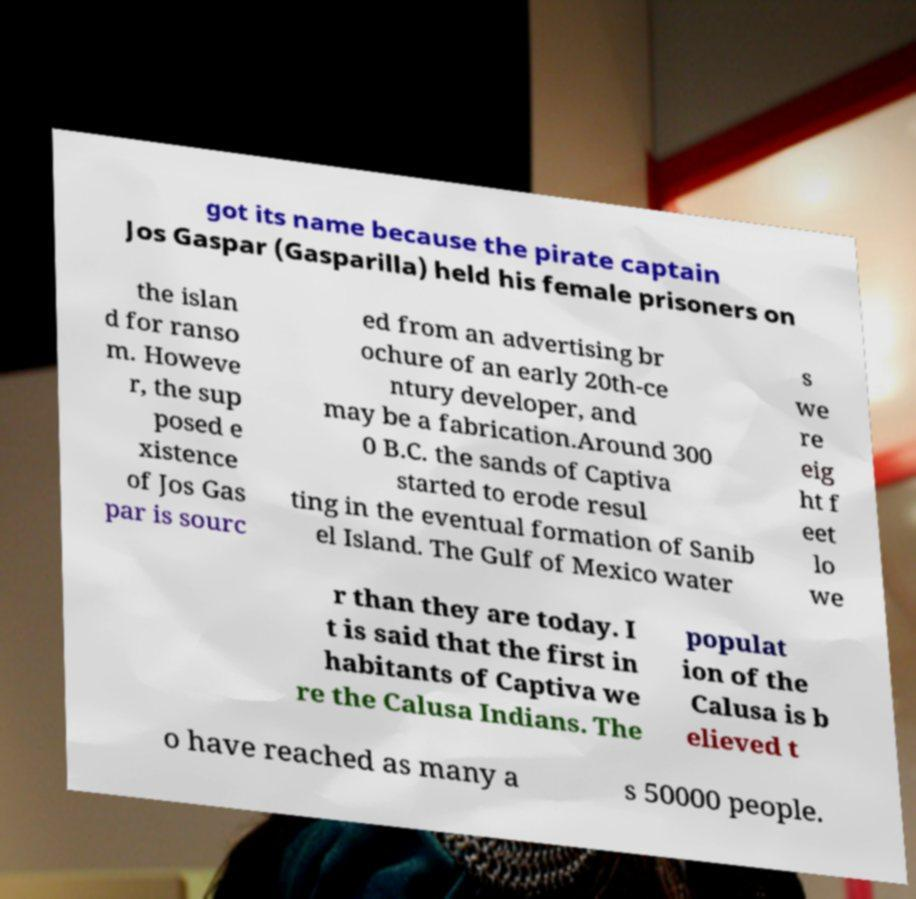Please read and relay the text visible in this image. What does it say? got its name because the pirate captain Jos Gaspar (Gasparilla) held his female prisoners on the islan d for ranso m. Howeve r, the sup posed e xistence of Jos Gas par is sourc ed from an advertising br ochure of an early 20th-ce ntury developer, and may be a fabrication.Around 300 0 B.C. the sands of Captiva started to erode resul ting in the eventual formation of Sanib el Island. The Gulf of Mexico water s we re eig ht f eet lo we r than they are today. I t is said that the first in habitants of Captiva we re the Calusa Indians. The populat ion of the Calusa is b elieved t o have reached as many a s 50000 people. 